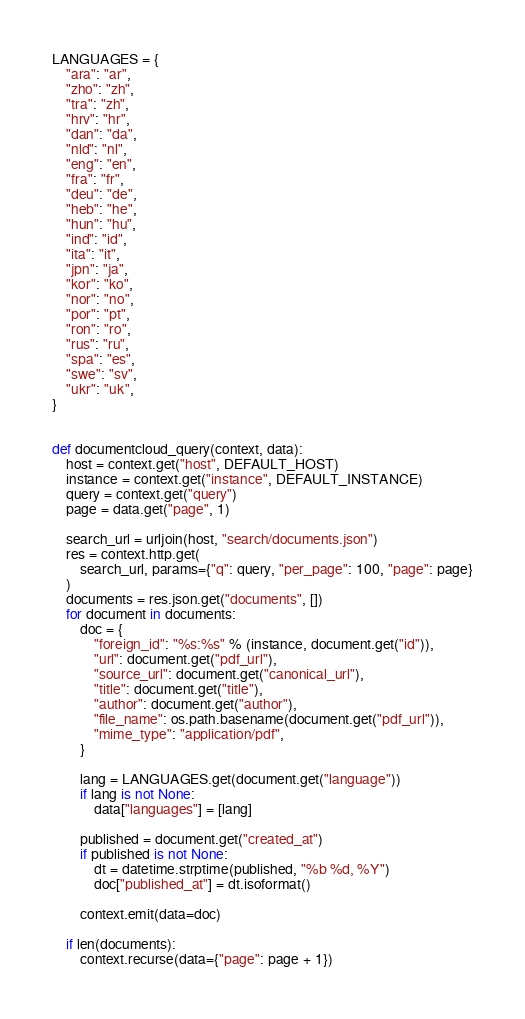<code> <loc_0><loc_0><loc_500><loc_500><_Python_>LANGUAGES = {
    "ara": "ar",
    "zho": "zh",
    "tra": "zh",
    "hrv": "hr",
    "dan": "da",
    "nld": "nl",
    "eng": "en",
    "fra": "fr",
    "deu": "de",
    "heb": "he",
    "hun": "hu",
    "ind": "id",
    "ita": "it",
    "jpn": "ja",
    "kor": "ko",
    "nor": "no",
    "por": "pt",
    "ron": "ro",
    "rus": "ru",
    "spa": "es",
    "swe": "sv",
    "ukr": "uk",
}


def documentcloud_query(context, data):
    host = context.get("host", DEFAULT_HOST)
    instance = context.get("instance", DEFAULT_INSTANCE)
    query = context.get("query")
    page = data.get("page", 1)

    search_url = urljoin(host, "search/documents.json")
    res = context.http.get(
        search_url, params={"q": query, "per_page": 100, "page": page}
    )
    documents = res.json.get("documents", [])
    for document in documents:
        doc = {
            "foreign_id": "%s:%s" % (instance, document.get("id")),
            "url": document.get("pdf_url"),
            "source_url": document.get("canonical_url"),
            "title": document.get("title"),
            "author": document.get("author"),
            "file_name": os.path.basename(document.get("pdf_url")),
            "mime_type": "application/pdf",
        }

        lang = LANGUAGES.get(document.get("language"))
        if lang is not None:
            data["languages"] = [lang]

        published = document.get("created_at")
        if published is not None:
            dt = datetime.strptime(published, "%b %d, %Y")
            doc["published_at"] = dt.isoformat()

        context.emit(data=doc)

    if len(documents):
        context.recurse(data={"page": page + 1})
</code> 